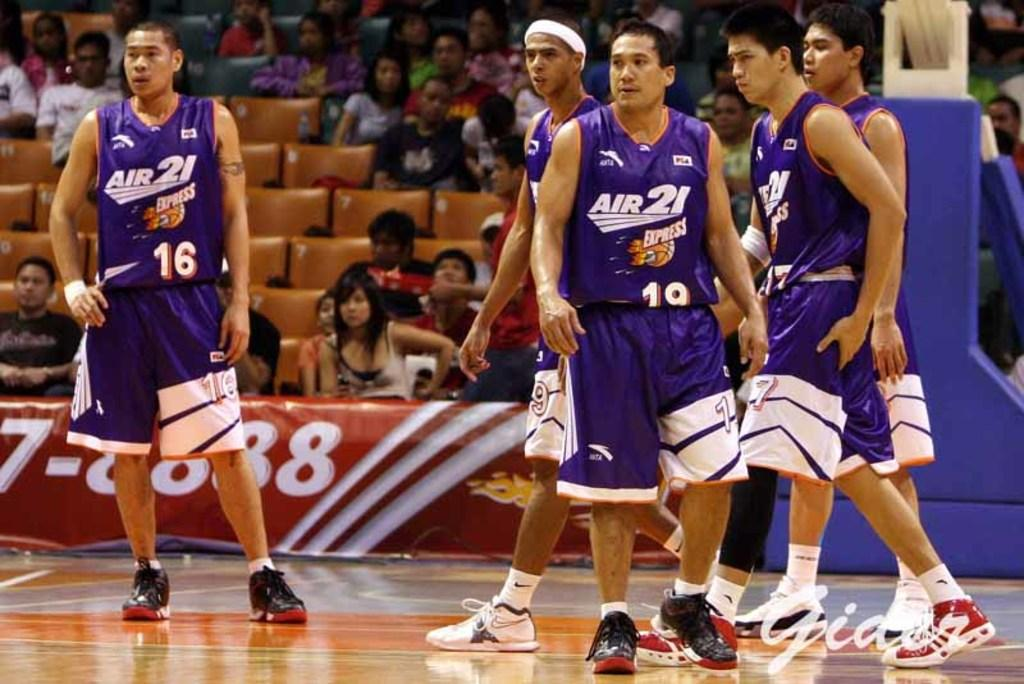<image>
Write a terse but informative summary of the picture. Members of the Air 21 Express basketball team stand on a basketball court. 